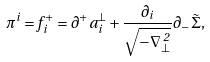Convert formula to latex. <formula><loc_0><loc_0><loc_500><loc_500>\pi ^ { i } = f ^ { + } _ { \, i } = \partial ^ { + } a _ { i } ^ { \bot } + \frac { \partial _ { i } } { \sqrt { - { \nabla } _ { \bot } ^ { \, 2 } } } \partial _ { - } \tilde { \Sigma } ,</formula> 